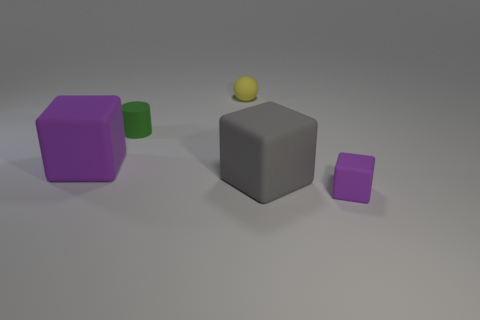Are there any other things that have the same shape as the small green matte thing?
Ensure brevity in your answer.  No. Is the number of large blue objects less than the number of big gray objects?
Provide a succinct answer. Yes. There is a purple object that is on the left side of the purple rubber block that is to the right of the large purple matte block; what number of small matte things are right of it?
Provide a succinct answer. 3. How big is the purple matte object to the right of the small yellow ball?
Give a very brief answer. Small. There is a tiny matte object that is on the right side of the tiny yellow object; is it the same shape as the gray thing?
Ensure brevity in your answer.  Yes. Are any small gray matte cylinders visible?
Offer a very short reply. No. Is the shape of the gray object the same as the purple rubber thing that is in front of the large purple block?
Offer a terse response. Yes. How many gray rubber things are the same shape as the big purple rubber object?
Provide a short and direct response. 1. What is the shape of the tiny green matte object?
Give a very brief answer. Cylinder. What is the size of the yellow rubber object behind the rubber block that is right of the gray matte thing?
Offer a very short reply. Small. 